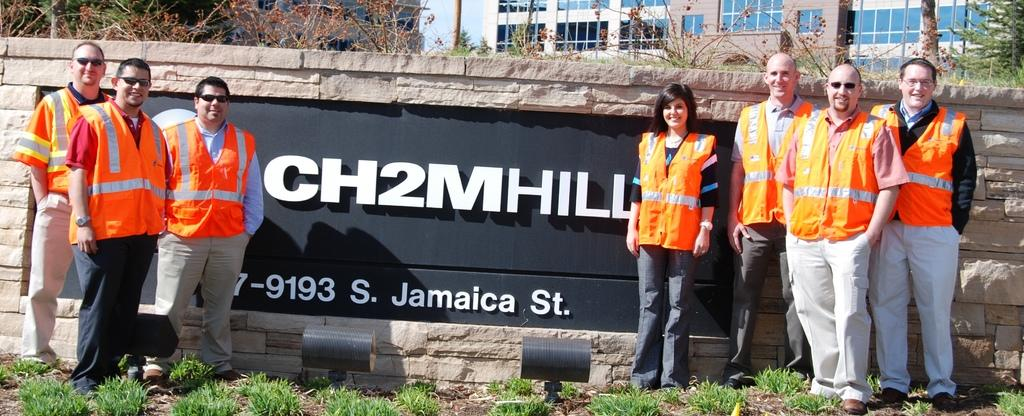What are the people in the image doing? The people in the image are standing beside a wall. What type of natural environment is visible in the image? There is grass visible in the image. What type of structure is present in the image? There is a building in the image. What other living organisms can be seen in the image? There are plants in the image. What is the tall, vertical object in the image? There is a pole in the image. What part of the natural environment is visible in the image? The sky is visible in the image. What type of door can be seen in the image? There is no door present in the image. What emotion is the boy expressing in the image? There is no boy present in the image. 